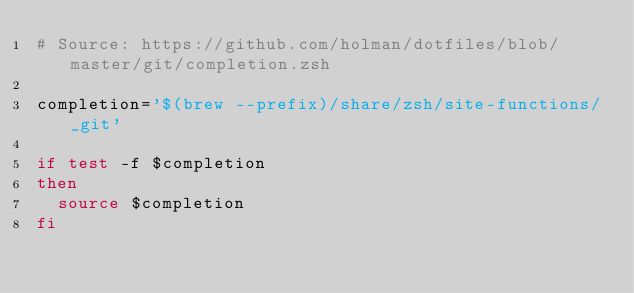Convert code to text. <code><loc_0><loc_0><loc_500><loc_500><_Bash_># Source: https://github.com/holman/dotfiles/blob/master/git/completion.zsh

completion='$(brew --prefix)/share/zsh/site-functions/_git'

if test -f $completion
then
  source $completion
fi
</code> 